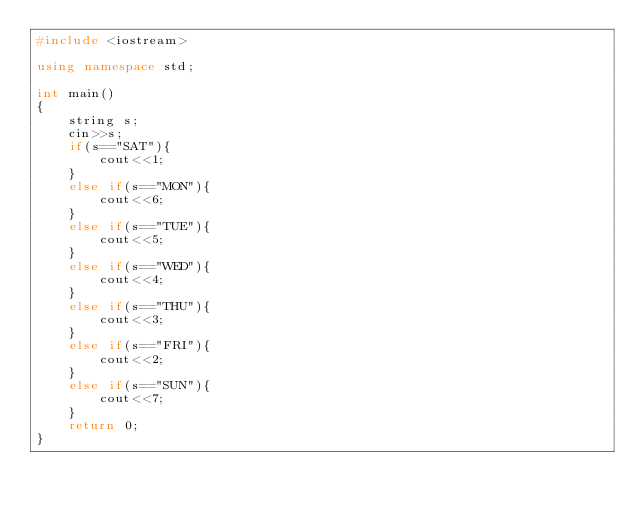Convert code to text. <code><loc_0><loc_0><loc_500><loc_500><_C++_>#include <iostream>

using namespace std;

int main()
{
    string s;
    cin>>s;
    if(s=="SAT"){
        cout<<1;
    }
    else if(s=="MON"){
        cout<<6;
    }
    else if(s=="TUE"){
        cout<<5;
    }
    else if(s=="WED"){
        cout<<4;
    }
    else if(s=="THU"){
        cout<<3;
    }
    else if(s=="FRI"){
        cout<<2;
    }
    else if(s=="SUN"){
        cout<<7;
    }
    return 0;
}
</code> 